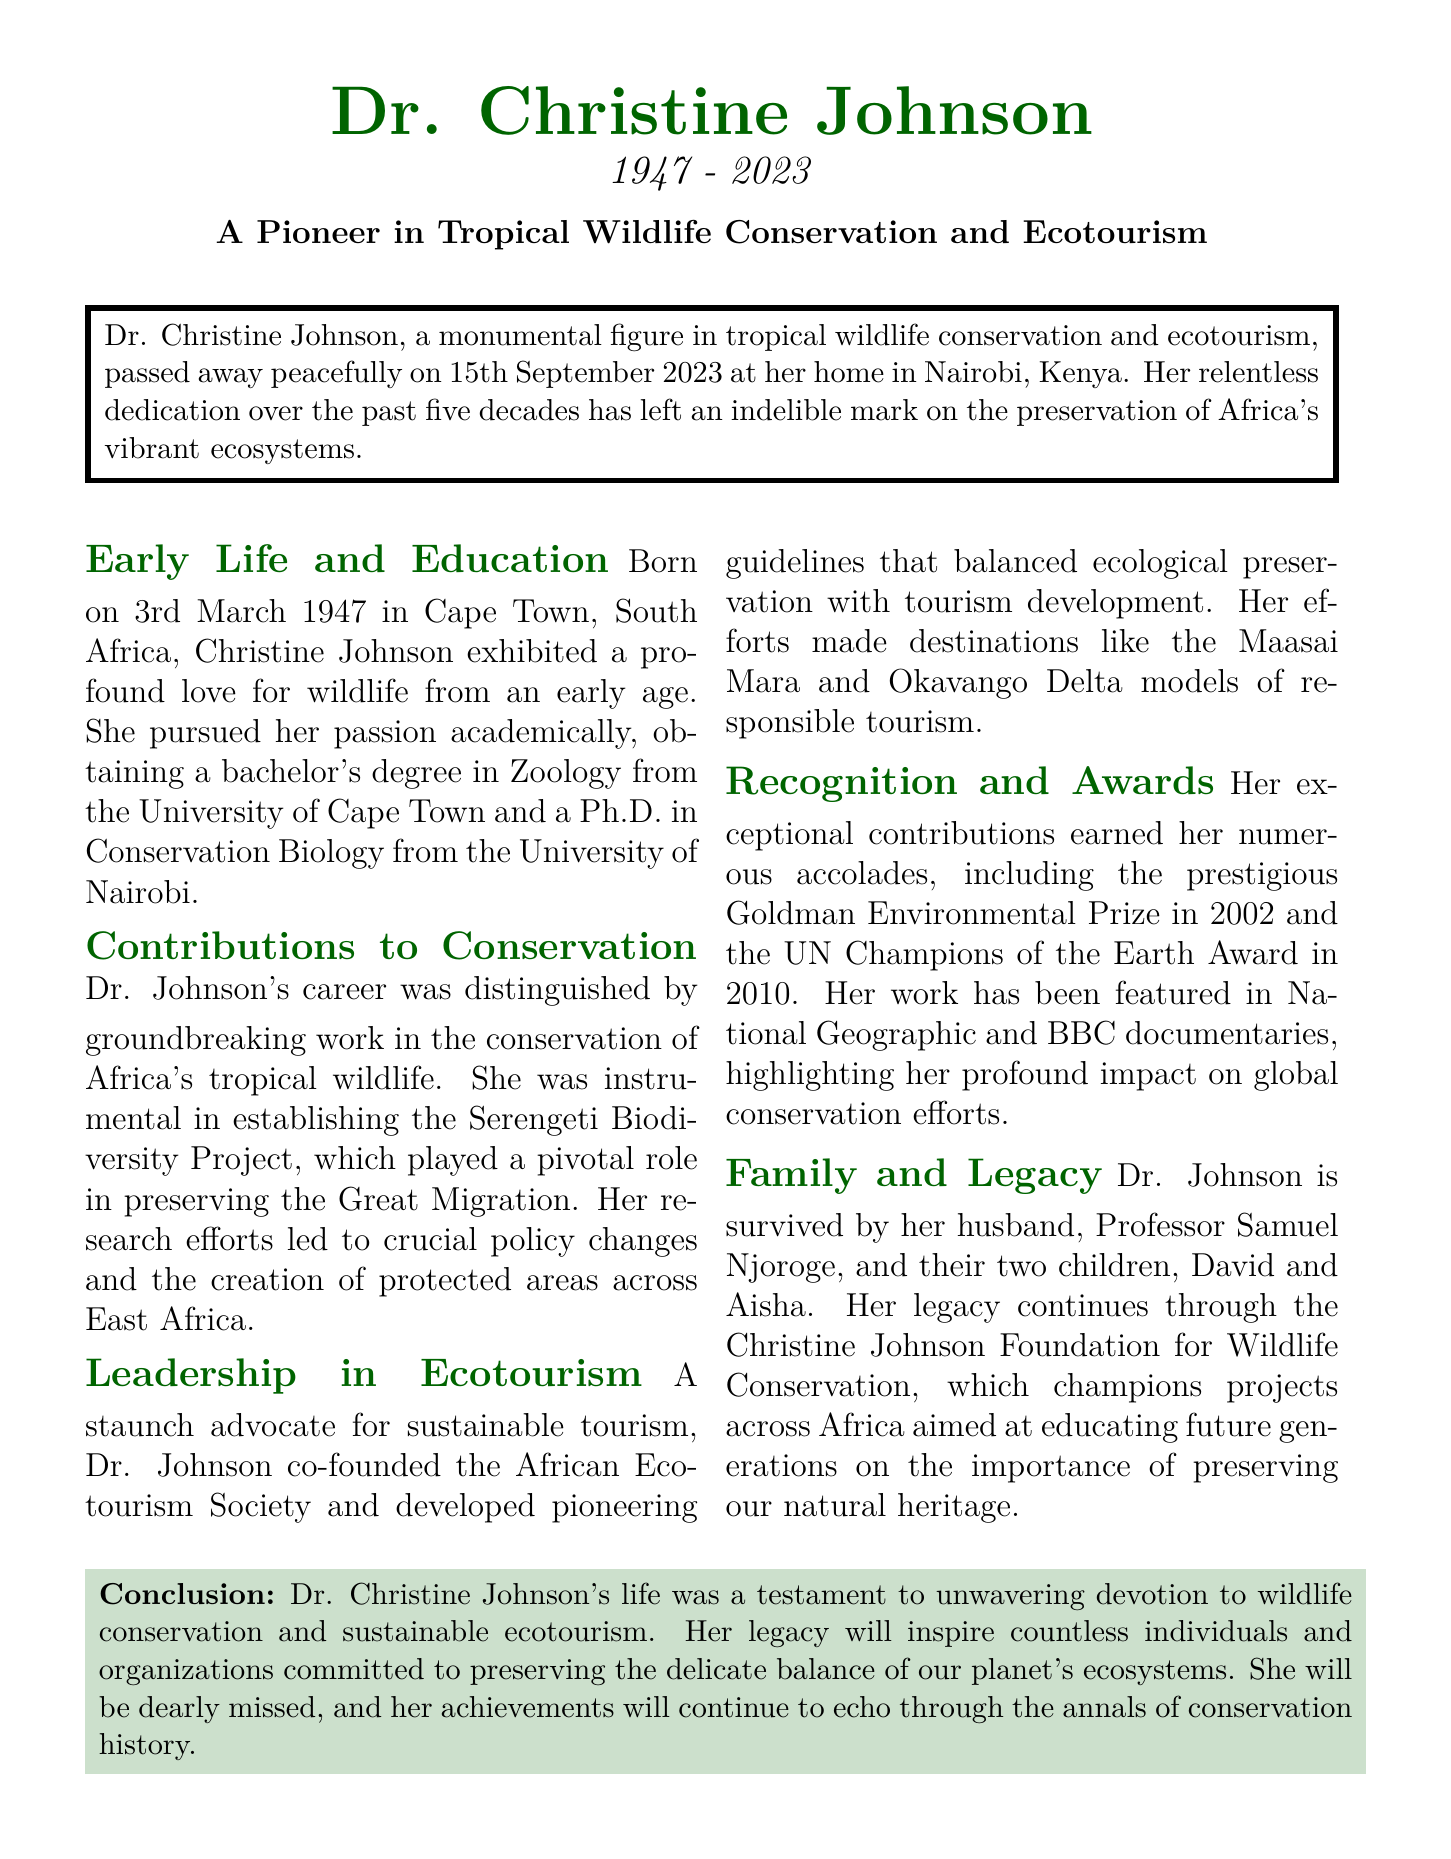What was Dr. Christine Johnson's date of birth? The document states that she was born on 3rd March 1947.
Answer: 3rd March 1947 When did Dr. Johnson pass away? The document notes her passing occurred on 15th September 2023.
Answer: 15th September 2023 What prestigious award did Dr. Johnson receive in 2010? The document mentions she received the UN Champions of the Earth Award in 2010.
Answer: UN Champions of the Earth Award Which project did Dr. Johnson establish that preserved the Great Migration? The document identifies the Serengeti Biodiversity Project as the significant project she established.
Answer: Serengeti Biodiversity Project What foundation did Dr. Johnson establish for wildlife conservation? The document indicates she established the Christine Johnson Foundation for Wildlife Conservation.
Answer: Christine Johnson Foundation for Wildlife Conservation What aspect of tourism did Dr. Johnson focus on? The document describes her as a staunch advocate for sustainable tourism.
Answer: Sustainable tourism How many children did Dr. Johnson have? The document states she is survived by two children, David and Aisha.
Answer: Two children What was Dr. Johnson's highest academic qualification? The document indicates she obtained a Ph.D. in Conservation Biology.
Answer: Ph.D. in Conservation Biology Which African ecotourism destinations are mentioned in relation to Dr. Johnson's work? The document lists the Maasai Mara and Okavango Delta as destinations she worked on.
Answer: Maasai Mara and Okavango Delta 